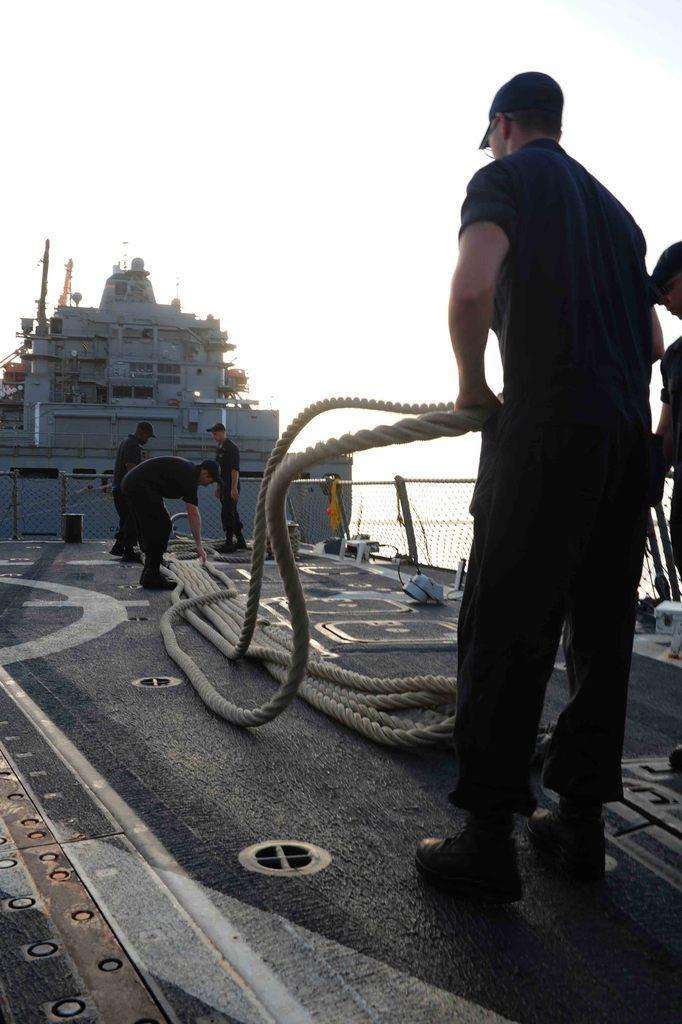Please provide a concise description of this image. On the right side, we see two men are standing and they are holding the ropes. In the middle, we see three men are standing and they are holding the ropes. They might be standing on the deck of ship. In the background, we see a ship in white color. In the background, we see the fence and the water. At the top, we see the sky. 